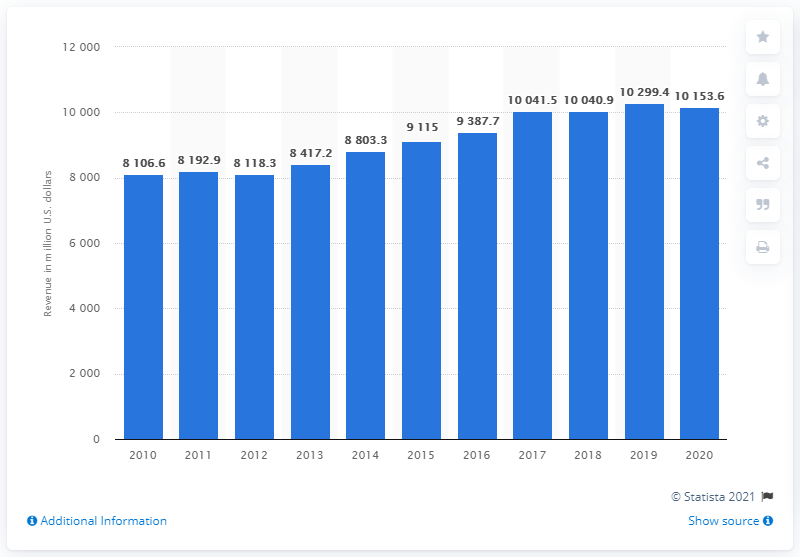List a handful of essential elements in this visual. Republic Services' revenue for the year ended December 31, 2020, was $10,153.60. 